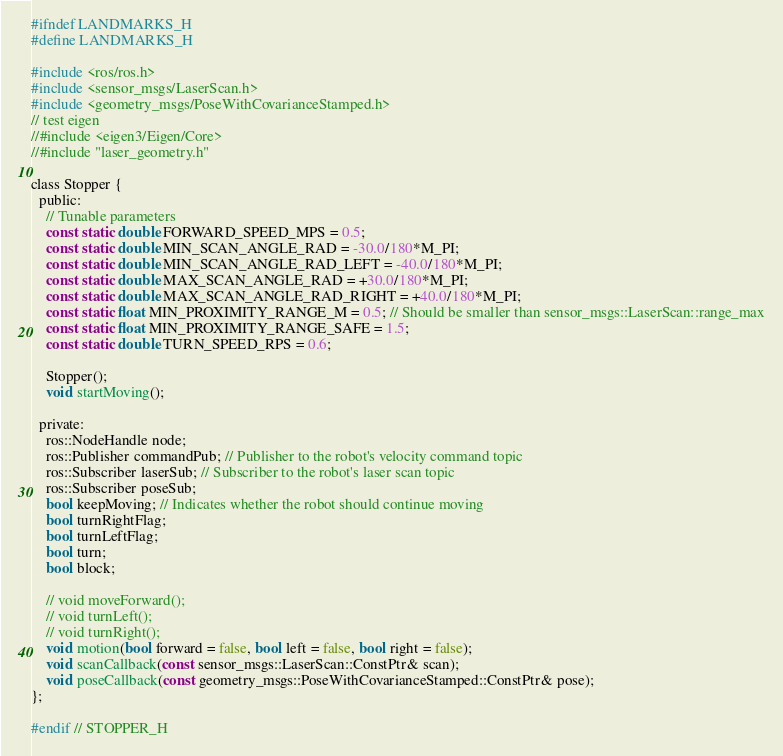<code> <loc_0><loc_0><loc_500><loc_500><_C_>#ifndef LANDMARKS_H
#define LANDMARKS_H

#include <ros/ros.h>
#include <sensor_msgs/LaserScan.h>
#include <geometry_msgs/PoseWithCovarianceStamped.h>
// test eigen
//#include <eigen3/Eigen/Core>
//#include "laser_geometry.h"

class Stopper {
  public:
    // Tunable parameters
    const static double FORWARD_SPEED_MPS = 0.5;
    const static double MIN_SCAN_ANGLE_RAD = -30.0/180*M_PI;
    const static double MIN_SCAN_ANGLE_RAD_LEFT = -40.0/180*M_PI;
    const static double MAX_SCAN_ANGLE_RAD = +30.0/180*M_PI;
    const static double MAX_SCAN_ANGLE_RAD_RIGHT = +40.0/180*M_PI;
    const static float MIN_PROXIMITY_RANGE_M = 0.5; // Should be smaller than sensor_msgs::LaserScan::range_max
    const static float MIN_PROXIMITY_RANGE_SAFE = 1.5;
    const static double TURN_SPEED_RPS = 0.6;

    Stopper();
    void startMoving();

  private:
    ros::NodeHandle node;
    ros::Publisher commandPub; // Publisher to the robot's velocity command topic
    ros::Subscriber laserSub; // Subscriber to the robot's laser scan topic
    ros::Subscriber poseSub;
    bool keepMoving; // Indicates whether the robot should continue moving
    bool turnRightFlag;
    bool turnLeftFlag;
    bool turn;
    bool block;

    // void moveForward();
    // void turnLeft();
    // void turnRight();
    void motion(bool forward = false, bool left = false, bool right = false);
    void scanCallback(const sensor_msgs::LaserScan::ConstPtr& scan);
    void poseCallback(const geometry_msgs::PoseWithCovarianceStamped::ConstPtr& pose);
};

#endif // STOPPER_H
</code> 